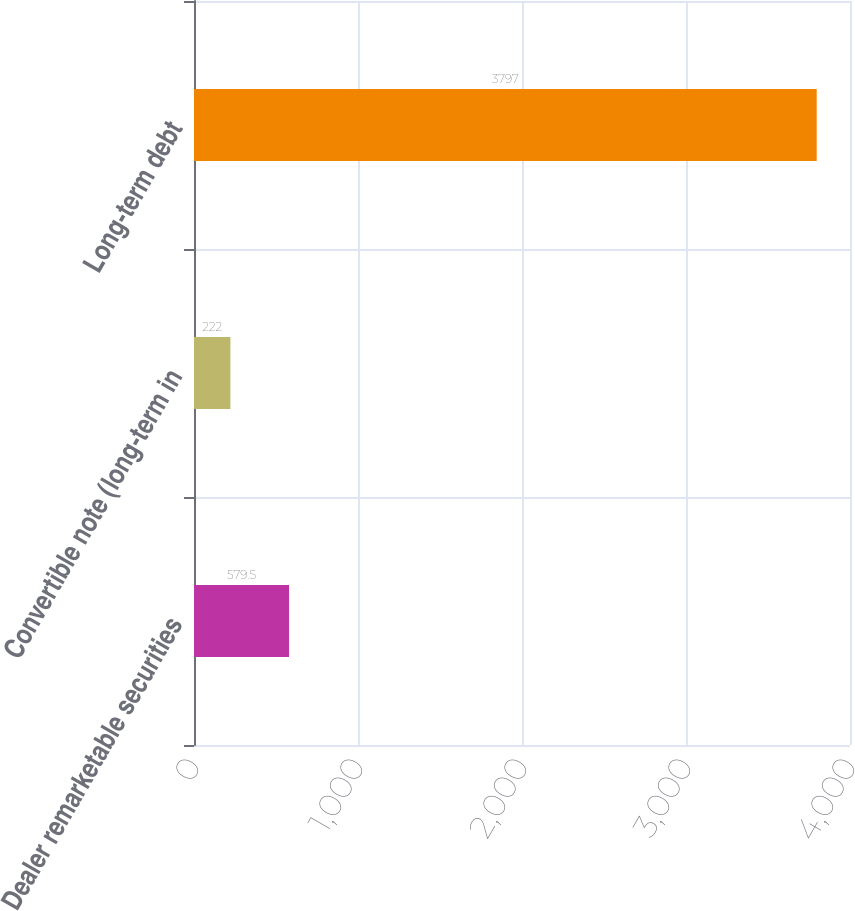Convert chart to OTSL. <chart><loc_0><loc_0><loc_500><loc_500><bar_chart><fcel>Dealer remarketable securities<fcel>Convertible note (long-term in<fcel>Long-term debt<nl><fcel>579.5<fcel>222<fcel>3797<nl></chart> 